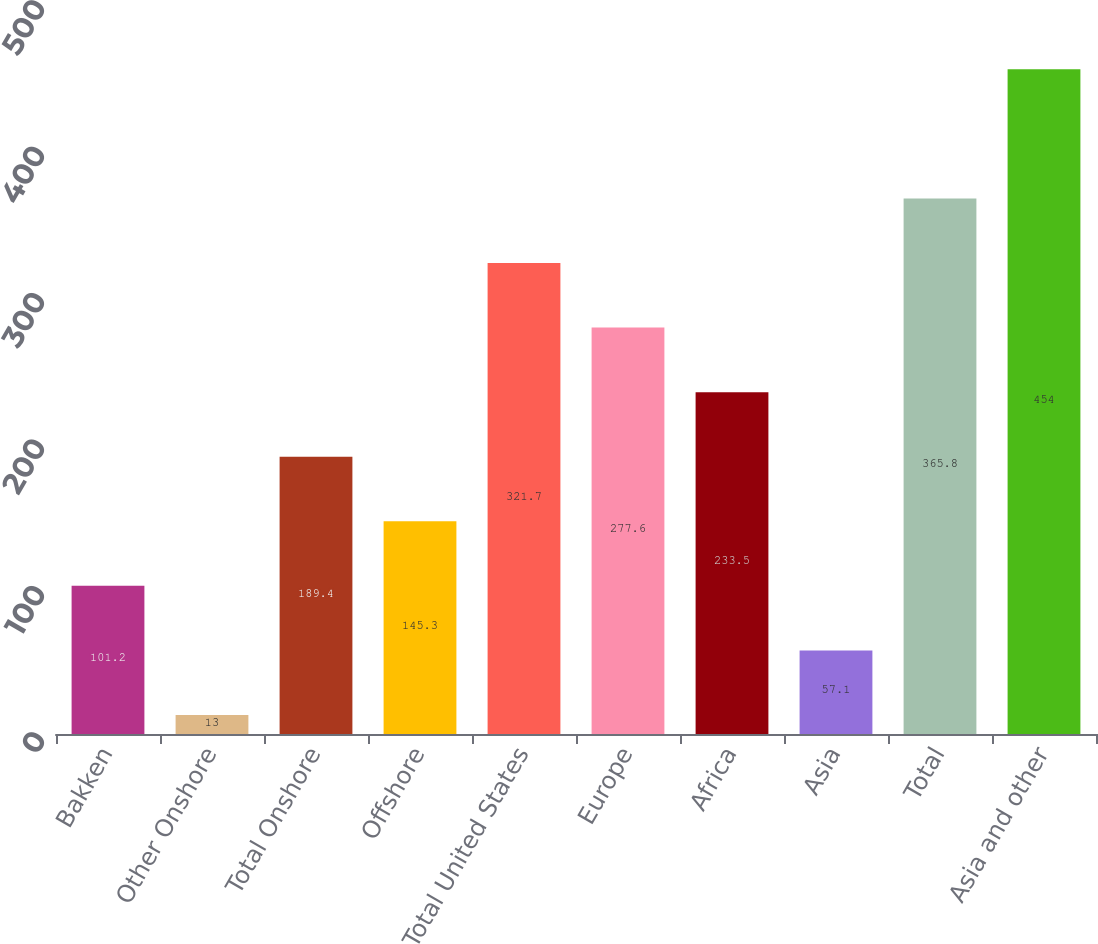Convert chart. <chart><loc_0><loc_0><loc_500><loc_500><bar_chart><fcel>Bakken<fcel>Other Onshore<fcel>Total Onshore<fcel>Offshore<fcel>Total United States<fcel>Europe<fcel>Africa<fcel>Asia<fcel>Total<fcel>Asia and other<nl><fcel>101.2<fcel>13<fcel>189.4<fcel>145.3<fcel>321.7<fcel>277.6<fcel>233.5<fcel>57.1<fcel>365.8<fcel>454<nl></chart> 